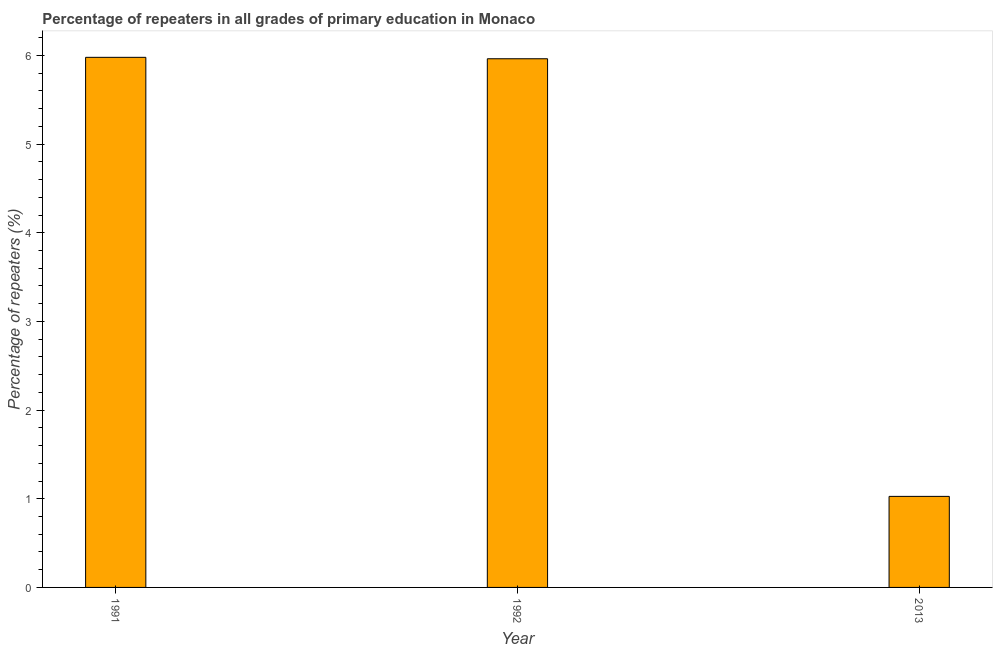Does the graph contain any zero values?
Your answer should be compact. No. Does the graph contain grids?
Provide a short and direct response. No. What is the title of the graph?
Keep it short and to the point. Percentage of repeaters in all grades of primary education in Monaco. What is the label or title of the Y-axis?
Ensure brevity in your answer.  Percentage of repeaters (%). What is the percentage of repeaters in primary education in 1992?
Provide a short and direct response. 5.96. Across all years, what is the maximum percentage of repeaters in primary education?
Offer a terse response. 5.98. Across all years, what is the minimum percentage of repeaters in primary education?
Your response must be concise. 1.03. In which year was the percentage of repeaters in primary education minimum?
Provide a short and direct response. 2013. What is the sum of the percentage of repeaters in primary education?
Your response must be concise. 12.97. What is the difference between the percentage of repeaters in primary education in 1991 and 2013?
Your response must be concise. 4.95. What is the average percentage of repeaters in primary education per year?
Offer a very short reply. 4.32. What is the median percentage of repeaters in primary education?
Your answer should be very brief. 5.96. In how many years, is the percentage of repeaters in primary education greater than 3.4 %?
Your answer should be very brief. 2. What is the ratio of the percentage of repeaters in primary education in 1992 to that in 2013?
Make the answer very short. 5.81. Is the difference between the percentage of repeaters in primary education in 1992 and 2013 greater than the difference between any two years?
Your answer should be very brief. No. What is the difference between the highest and the second highest percentage of repeaters in primary education?
Keep it short and to the point. 0.02. What is the difference between the highest and the lowest percentage of repeaters in primary education?
Offer a terse response. 4.95. In how many years, is the percentage of repeaters in primary education greater than the average percentage of repeaters in primary education taken over all years?
Keep it short and to the point. 2. Are all the bars in the graph horizontal?
Make the answer very short. No. How many years are there in the graph?
Make the answer very short. 3. Are the values on the major ticks of Y-axis written in scientific E-notation?
Offer a terse response. No. What is the Percentage of repeaters (%) of 1991?
Offer a very short reply. 5.98. What is the Percentage of repeaters (%) in 1992?
Offer a very short reply. 5.96. What is the Percentage of repeaters (%) of 2013?
Your response must be concise. 1.03. What is the difference between the Percentage of repeaters (%) in 1991 and 1992?
Provide a succinct answer. 0.02. What is the difference between the Percentage of repeaters (%) in 1991 and 2013?
Your answer should be very brief. 4.95. What is the difference between the Percentage of repeaters (%) in 1992 and 2013?
Give a very brief answer. 4.94. What is the ratio of the Percentage of repeaters (%) in 1991 to that in 1992?
Your answer should be compact. 1. What is the ratio of the Percentage of repeaters (%) in 1991 to that in 2013?
Offer a terse response. 5.82. What is the ratio of the Percentage of repeaters (%) in 1992 to that in 2013?
Your answer should be very brief. 5.81. 